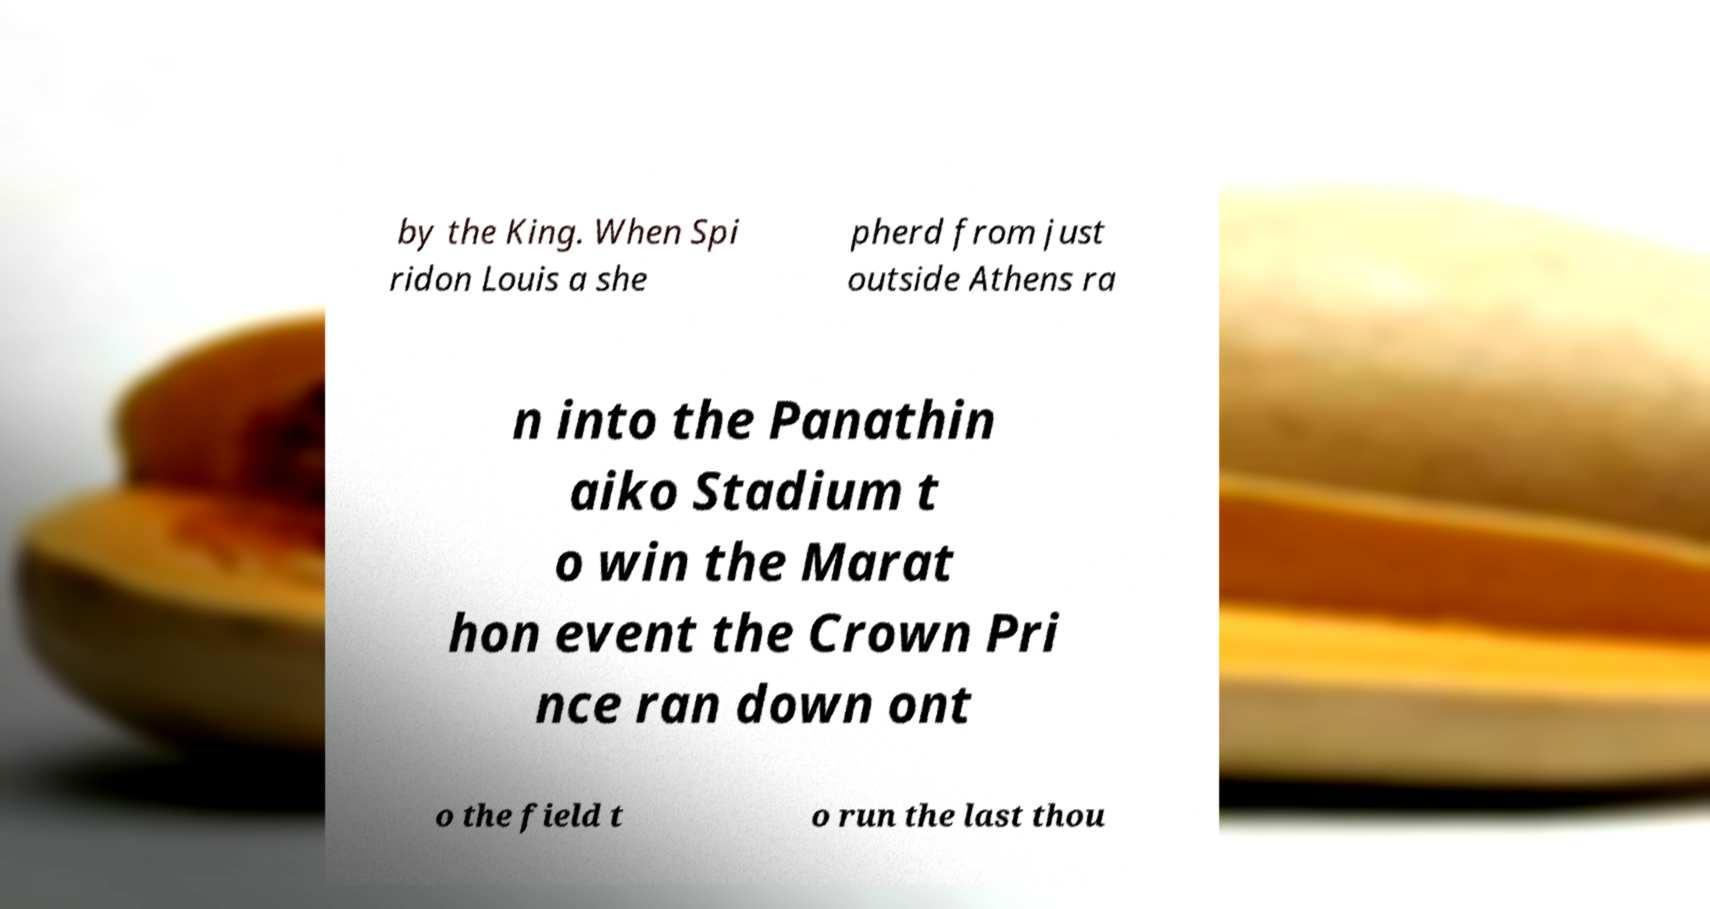Could you extract and type out the text from this image? by the King. When Spi ridon Louis a she pherd from just outside Athens ra n into the Panathin aiko Stadium t o win the Marat hon event the Crown Pri nce ran down ont o the field t o run the last thou 